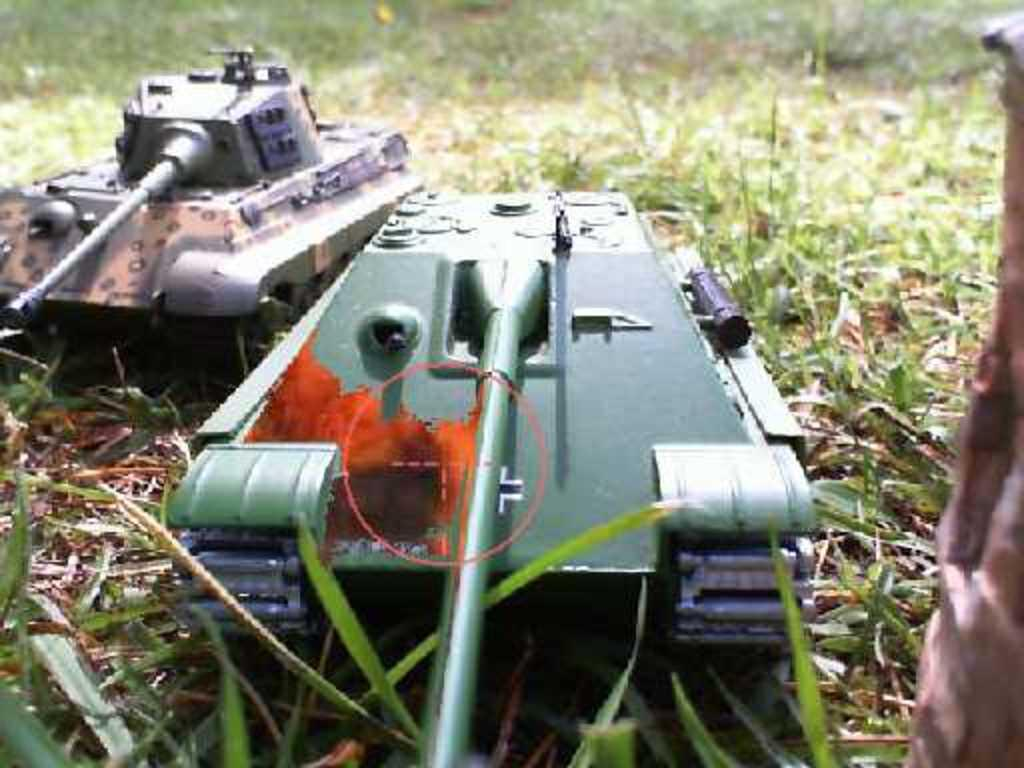What type of terrain is visible in the image? Ground and grass are visible in the image. What objects are present in the image? There are two miniature military tanks inature military tanks in the image. What colors are the tanks? The tanks are green, orange, brown, and black in color. Can you see the smile on the needle in the image? There is no smile or needle present in the image. 